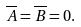<formula> <loc_0><loc_0><loc_500><loc_500>\overline { A } = \overline { B } = 0 .</formula> 